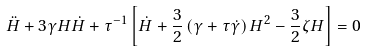Convert formula to latex. <formula><loc_0><loc_0><loc_500><loc_500>\ddot { H } + 3 \gamma H \dot { H } + \tau ^ { - 1 } \left [ \dot { H } + \frac { 3 } { 2 } \left ( \gamma + \tau \dot { \gamma } \right ) H ^ { 2 } - \frac { 3 } { 2 } \zeta H \right ] = 0</formula> 